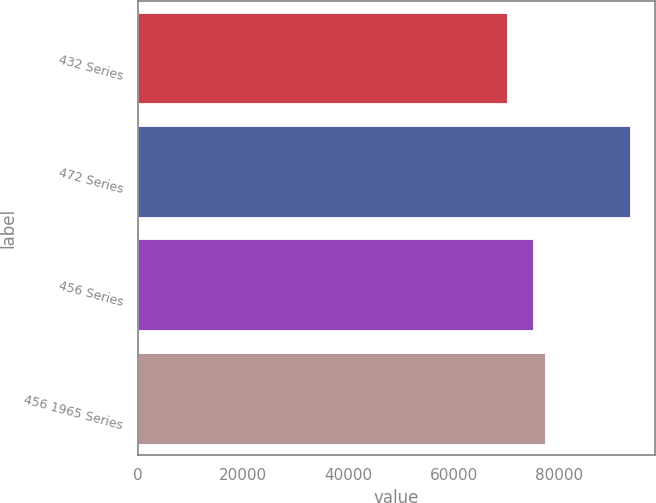Convert chart to OTSL. <chart><loc_0><loc_0><loc_500><loc_500><bar_chart><fcel>432 Series<fcel>472 Series<fcel>456 Series<fcel>456 1965 Series<nl><fcel>70000<fcel>93500<fcel>75000<fcel>77350<nl></chart> 